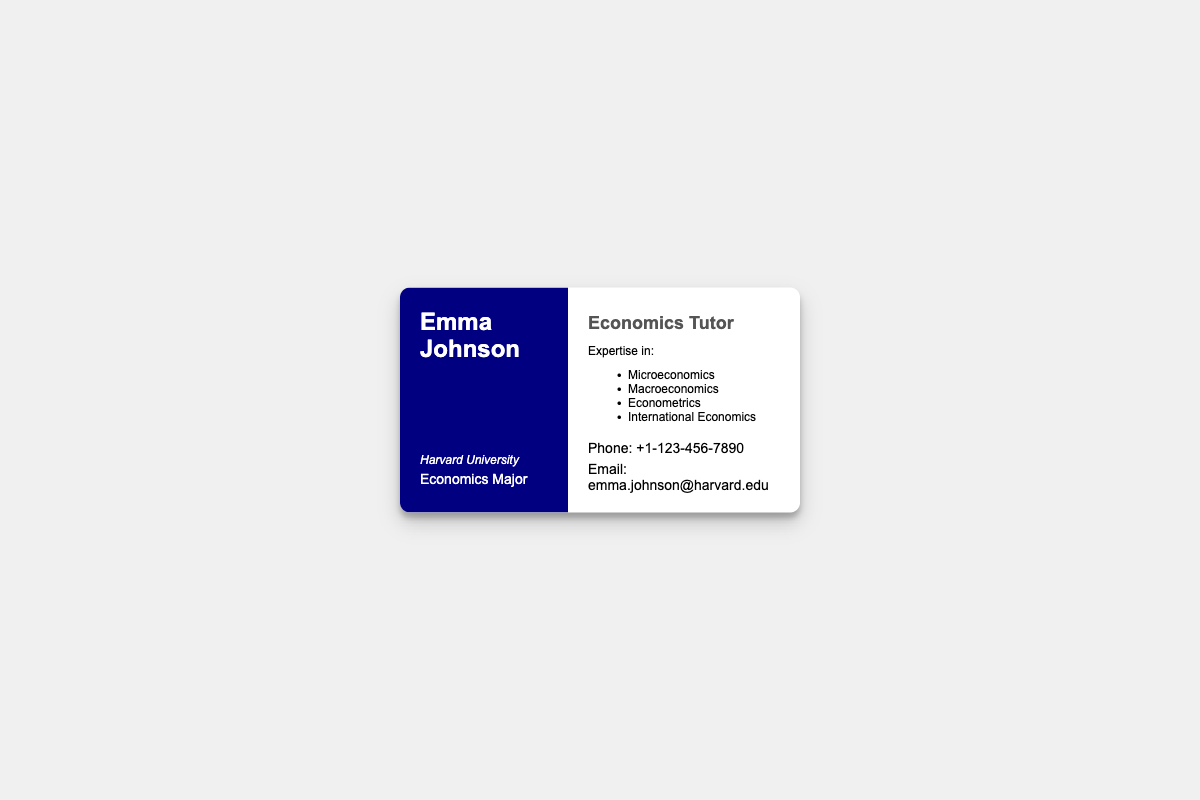What is the name on the business card? The name displayed prominently on the card is 'Emma Johnson'.
Answer: Emma Johnson What major is highlighted on the card? The card indicates the area of study for the individual, which is 'Economics Major'.
Answer: Economics Major What university did the individual attend? The card specifies the educational institution attended by the individual, which is 'Harvard University'.
Answer: Harvard University What are two areas of expertise mentioned? The card lists various areas the individual specializes in, including 'Microeconomics' and 'Macroeconomics'.
Answer: Microeconomics, Macroeconomics What is the phone number provided? The card includes a contact number, which can be retrieved directly as ' +1-123-456-7890'.
Answer: +1-123-456-7890 How many areas of expertise are listed? The card presents a total of four specific areas of expertise that the individual offers tutoring in.
Answer: Four What is the title of the individual? The card clearly states the professional role of the individual, which is 'Economics Tutor'.
Answer: Economics Tutor Which side of the business card contains the contact information? The contact information is found on the 'right-side' of the card layout.
Answer: Right side What design element is used in the business card? The card features a specific design element that enhances its appearance, noted as an 'elegant border design'.
Answer: Elegant border design 